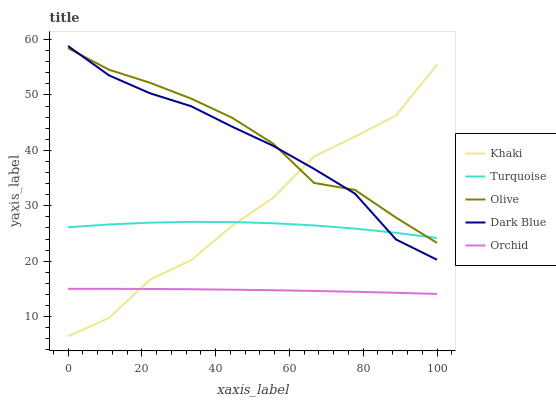Does Orchid have the minimum area under the curve?
Answer yes or no. Yes. Does Olive have the maximum area under the curve?
Answer yes or no. Yes. Does Dark Blue have the minimum area under the curve?
Answer yes or no. No. Does Dark Blue have the maximum area under the curve?
Answer yes or no. No. Is Orchid the smoothest?
Answer yes or no. Yes. Is Khaki the roughest?
Answer yes or no. Yes. Is Dark Blue the smoothest?
Answer yes or no. No. Is Dark Blue the roughest?
Answer yes or no. No. Does Dark Blue have the lowest value?
Answer yes or no. No. Does Turquoise have the highest value?
Answer yes or no. No. Is Orchid less than Dark Blue?
Answer yes or no. Yes. Is Turquoise greater than Orchid?
Answer yes or no. Yes. Does Orchid intersect Dark Blue?
Answer yes or no. No. 